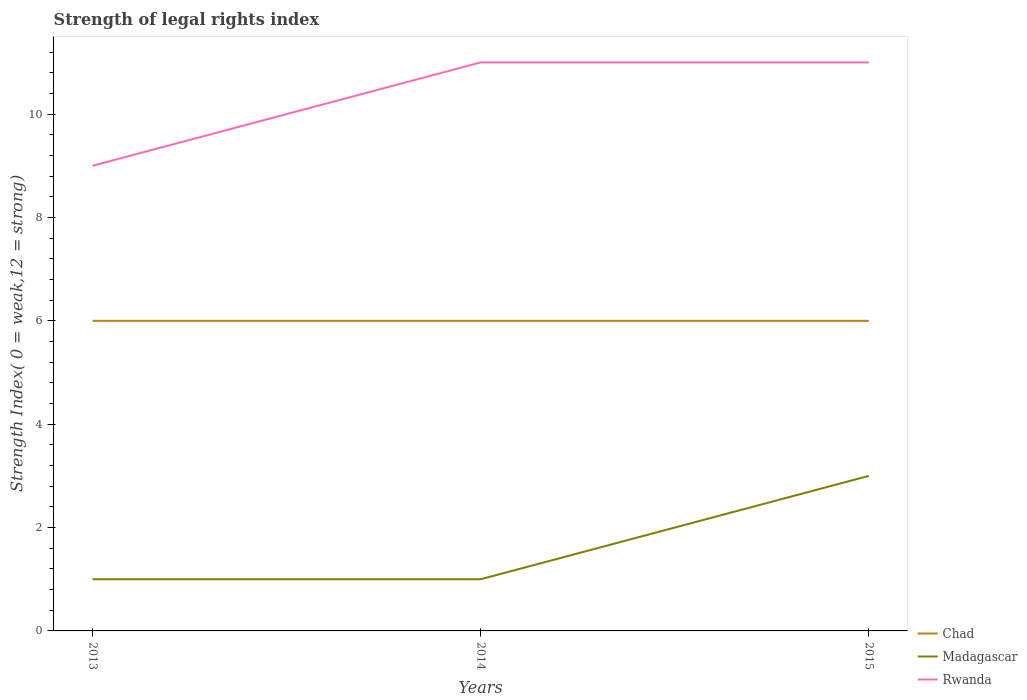Does the line corresponding to Rwanda intersect with the line corresponding to Madagascar?
Offer a terse response. No. Across all years, what is the maximum strength index in Rwanda?
Your response must be concise. 9. What is the total strength index in Madagascar in the graph?
Provide a short and direct response. -2. What is the difference between the highest and the second highest strength index in Madagascar?
Your answer should be very brief. 2. How many years are there in the graph?
Provide a short and direct response. 3. Where does the legend appear in the graph?
Provide a succinct answer. Bottom right. How many legend labels are there?
Give a very brief answer. 3. What is the title of the graph?
Give a very brief answer. Strength of legal rights index. Does "New Caledonia" appear as one of the legend labels in the graph?
Your answer should be very brief. No. What is the label or title of the X-axis?
Make the answer very short. Years. What is the label or title of the Y-axis?
Make the answer very short. Strength Index( 0 = weak,12 = strong). What is the Strength Index( 0 = weak,12 = strong) in Chad in 2013?
Your response must be concise. 6. What is the Strength Index( 0 = weak,12 = strong) of Chad in 2014?
Ensure brevity in your answer.  6. What is the Strength Index( 0 = weak,12 = strong) in Rwanda in 2014?
Your answer should be very brief. 11. What is the Strength Index( 0 = weak,12 = strong) of Chad in 2015?
Your response must be concise. 6. What is the Strength Index( 0 = weak,12 = strong) in Rwanda in 2015?
Your response must be concise. 11. What is the total Strength Index( 0 = weak,12 = strong) of Madagascar in the graph?
Provide a short and direct response. 5. What is the difference between the Strength Index( 0 = weak,12 = strong) in Chad in 2013 and that in 2014?
Your answer should be compact. 0. What is the difference between the Strength Index( 0 = weak,12 = strong) in Madagascar in 2013 and that in 2014?
Your response must be concise. 0. What is the difference between the Strength Index( 0 = weak,12 = strong) in Chad in 2013 and that in 2015?
Offer a terse response. 0. What is the difference between the Strength Index( 0 = weak,12 = strong) in Chad in 2014 and that in 2015?
Your answer should be compact. 0. What is the difference between the Strength Index( 0 = weak,12 = strong) of Chad in 2013 and the Strength Index( 0 = weak,12 = strong) of Rwanda in 2014?
Provide a succinct answer. -5. What is the difference between the Strength Index( 0 = weak,12 = strong) of Chad in 2013 and the Strength Index( 0 = weak,12 = strong) of Madagascar in 2015?
Make the answer very short. 3. What is the difference between the Strength Index( 0 = weak,12 = strong) in Chad in 2013 and the Strength Index( 0 = weak,12 = strong) in Rwanda in 2015?
Give a very brief answer. -5. What is the difference between the Strength Index( 0 = weak,12 = strong) of Madagascar in 2013 and the Strength Index( 0 = weak,12 = strong) of Rwanda in 2015?
Keep it short and to the point. -10. What is the difference between the Strength Index( 0 = weak,12 = strong) in Chad in 2014 and the Strength Index( 0 = weak,12 = strong) in Rwanda in 2015?
Ensure brevity in your answer.  -5. What is the difference between the Strength Index( 0 = weak,12 = strong) of Madagascar in 2014 and the Strength Index( 0 = weak,12 = strong) of Rwanda in 2015?
Your answer should be compact. -10. What is the average Strength Index( 0 = weak,12 = strong) of Madagascar per year?
Keep it short and to the point. 1.67. What is the average Strength Index( 0 = weak,12 = strong) of Rwanda per year?
Offer a very short reply. 10.33. In the year 2013, what is the difference between the Strength Index( 0 = weak,12 = strong) of Madagascar and Strength Index( 0 = weak,12 = strong) of Rwanda?
Ensure brevity in your answer.  -8. In the year 2015, what is the difference between the Strength Index( 0 = weak,12 = strong) of Chad and Strength Index( 0 = weak,12 = strong) of Rwanda?
Your answer should be compact. -5. In the year 2015, what is the difference between the Strength Index( 0 = weak,12 = strong) of Madagascar and Strength Index( 0 = weak,12 = strong) of Rwanda?
Give a very brief answer. -8. What is the ratio of the Strength Index( 0 = weak,12 = strong) of Madagascar in 2013 to that in 2014?
Your answer should be compact. 1. What is the ratio of the Strength Index( 0 = weak,12 = strong) in Rwanda in 2013 to that in 2014?
Provide a succinct answer. 0.82. What is the ratio of the Strength Index( 0 = weak,12 = strong) of Chad in 2013 to that in 2015?
Make the answer very short. 1. What is the ratio of the Strength Index( 0 = weak,12 = strong) of Madagascar in 2013 to that in 2015?
Keep it short and to the point. 0.33. What is the ratio of the Strength Index( 0 = weak,12 = strong) in Rwanda in 2013 to that in 2015?
Offer a terse response. 0.82. What is the difference between the highest and the lowest Strength Index( 0 = weak,12 = strong) of Chad?
Provide a succinct answer. 0. What is the difference between the highest and the lowest Strength Index( 0 = weak,12 = strong) of Rwanda?
Ensure brevity in your answer.  2. 